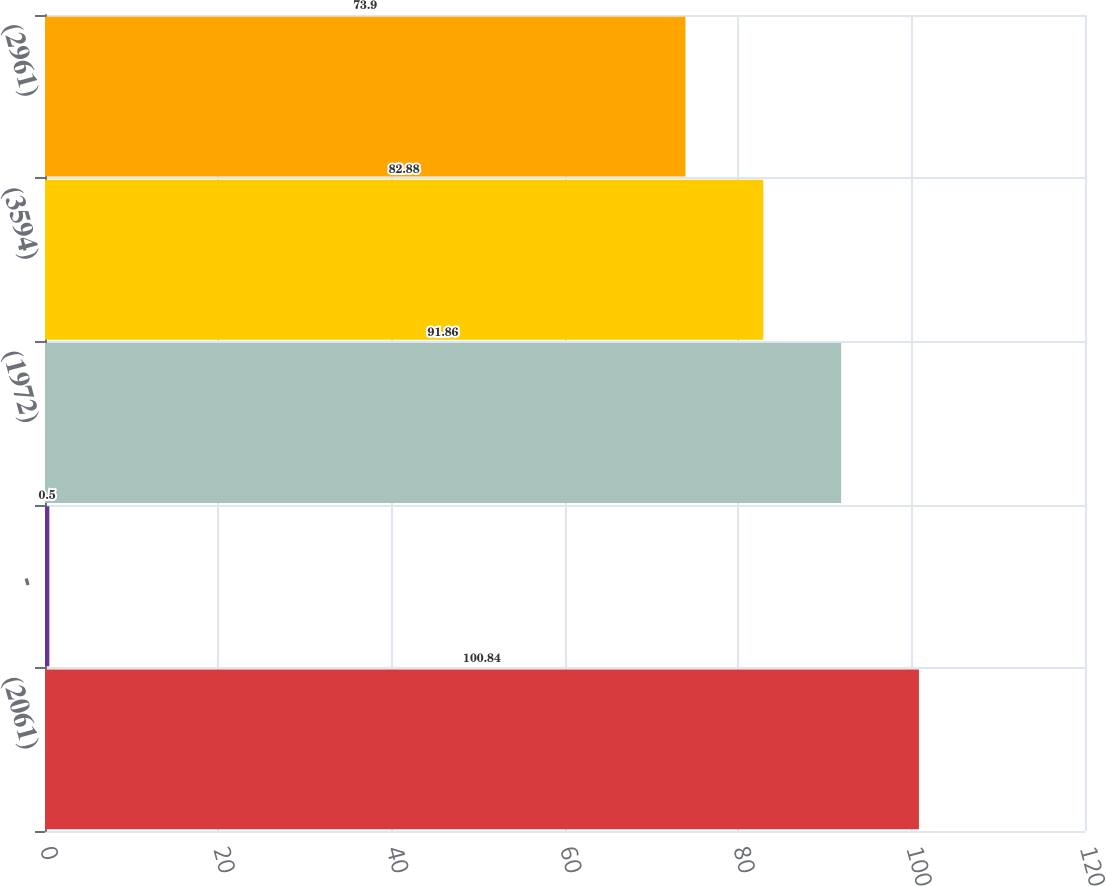Convert chart. <chart><loc_0><loc_0><loc_500><loc_500><bar_chart><fcel>(2061)<fcel>-<fcel>(1972)<fcel>(3594)<fcel>(2961)<nl><fcel>100.84<fcel>0.5<fcel>91.86<fcel>82.88<fcel>73.9<nl></chart> 